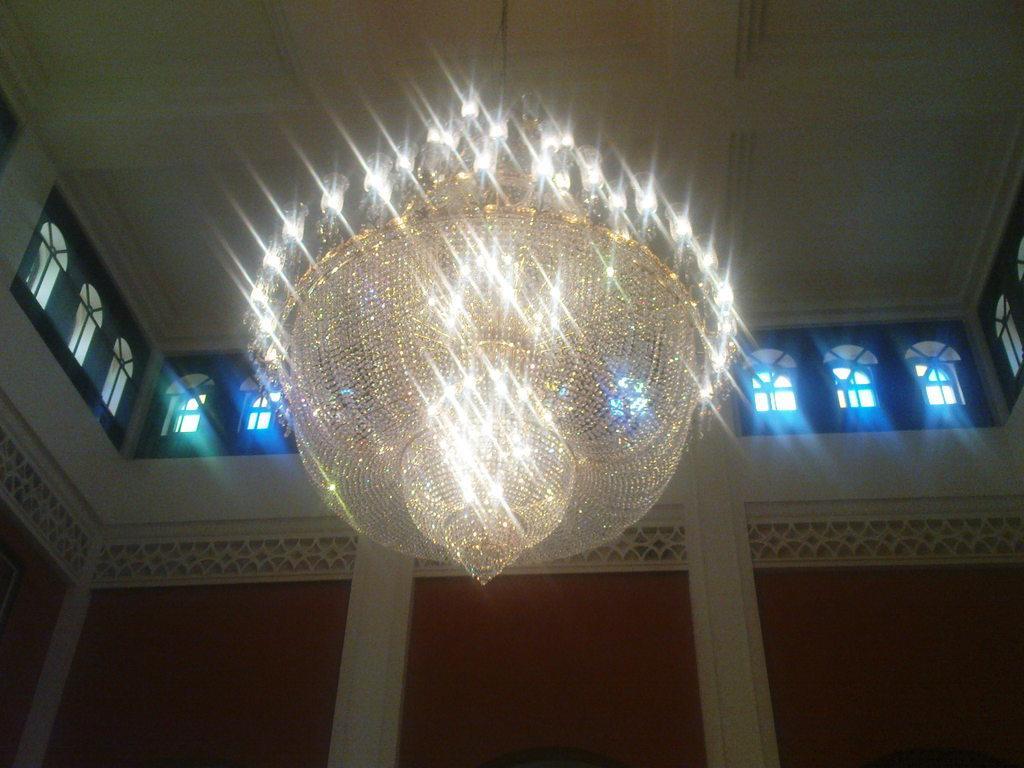Could you give a brief overview of what you see in this image? This image is clicked inside a building. There are lights in the middle. There are windows in the middle. 